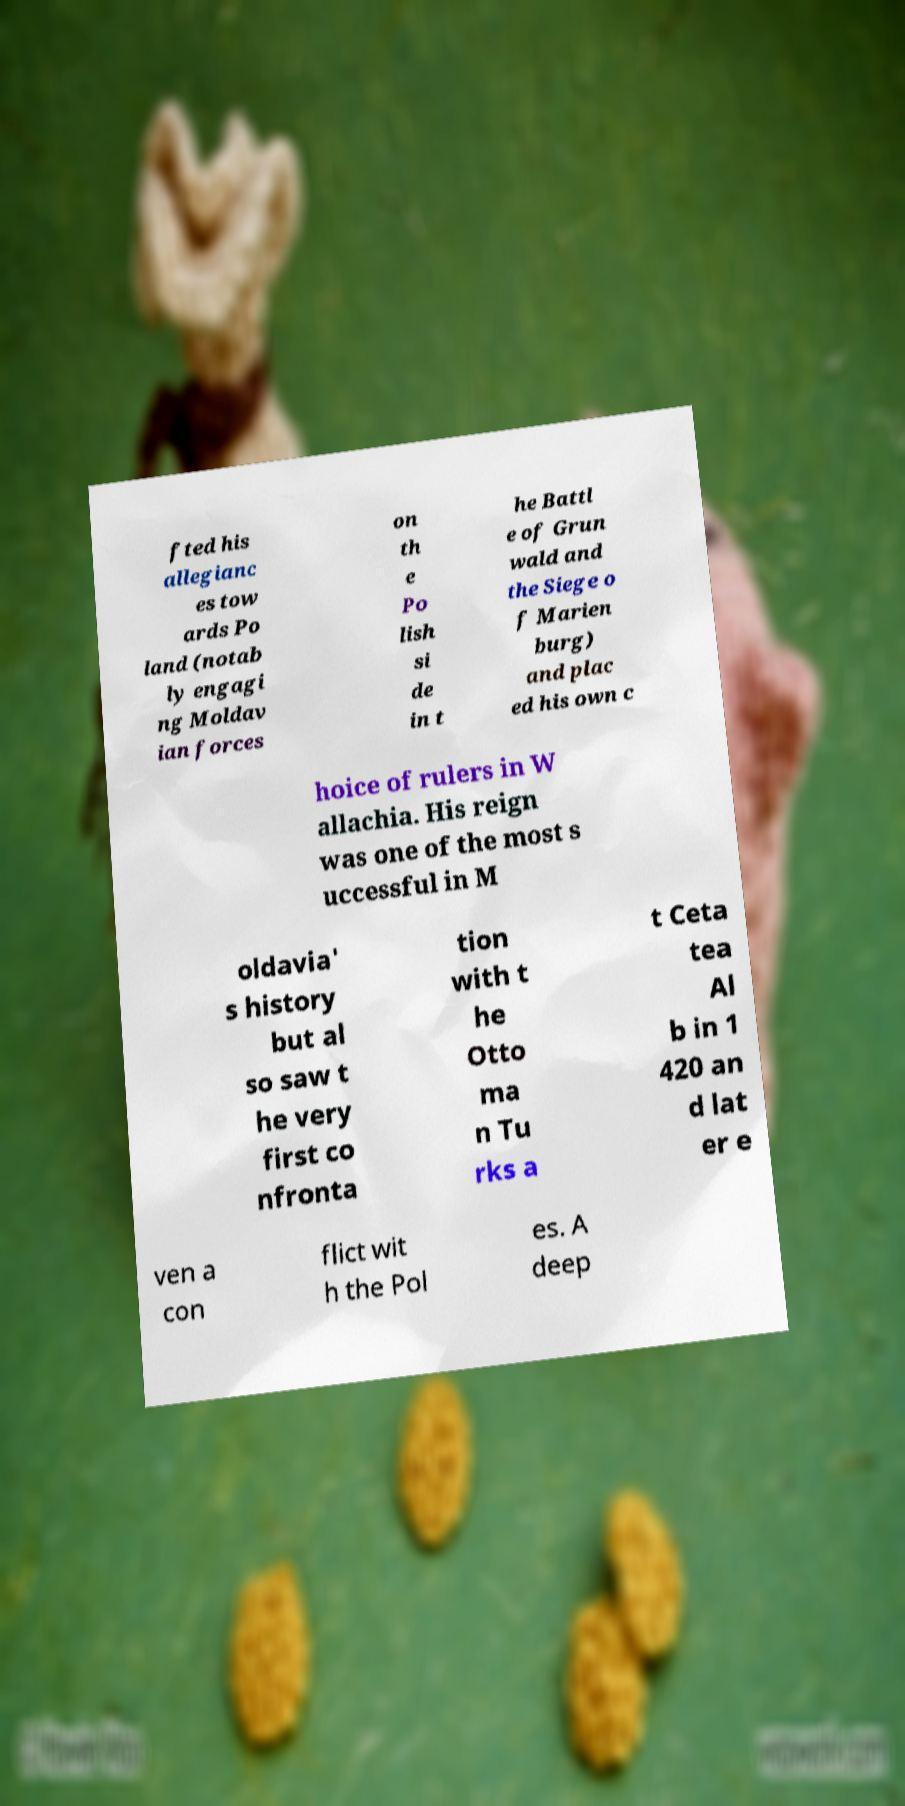There's text embedded in this image that I need extracted. Can you transcribe it verbatim? fted his allegianc es tow ards Po land (notab ly engagi ng Moldav ian forces on th e Po lish si de in t he Battl e of Grun wald and the Siege o f Marien burg) and plac ed his own c hoice of rulers in W allachia. His reign was one of the most s uccessful in M oldavia' s history but al so saw t he very first co nfronta tion with t he Otto ma n Tu rks a t Ceta tea Al b in 1 420 an d lat er e ven a con flict wit h the Pol es. A deep 